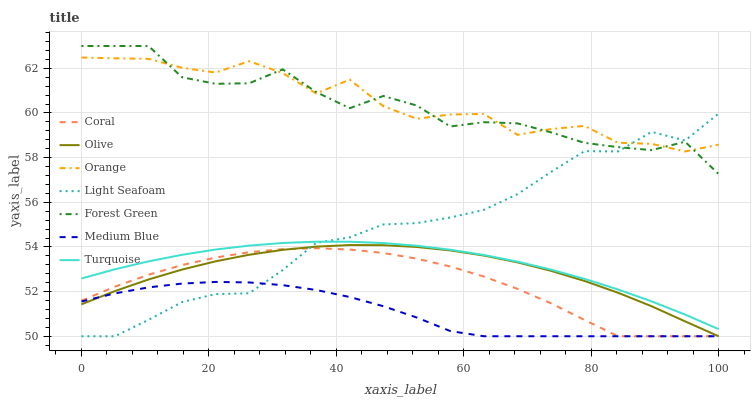Does Medium Blue have the minimum area under the curve?
Answer yes or no. Yes. Does Orange have the maximum area under the curve?
Answer yes or no. Yes. Does Coral have the minimum area under the curve?
Answer yes or no. No. Does Coral have the maximum area under the curve?
Answer yes or no. No. Is Turquoise the smoothest?
Answer yes or no. Yes. Is Forest Green the roughest?
Answer yes or no. Yes. Is Coral the smoothest?
Answer yes or no. No. Is Coral the roughest?
Answer yes or no. No. Does Coral have the lowest value?
Answer yes or no. Yes. Does Orange have the lowest value?
Answer yes or no. No. Does Forest Green have the highest value?
Answer yes or no. Yes. Does Coral have the highest value?
Answer yes or no. No. Is Olive less than Orange?
Answer yes or no. Yes. Is Forest Green greater than Coral?
Answer yes or no. Yes. Does Turquoise intersect Light Seafoam?
Answer yes or no. Yes. Is Turquoise less than Light Seafoam?
Answer yes or no. No. Is Turquoise greater than Light Seafoam?
Answer yes or no. No. Does Olive intersect Orange?
Answer yes or no. No. 